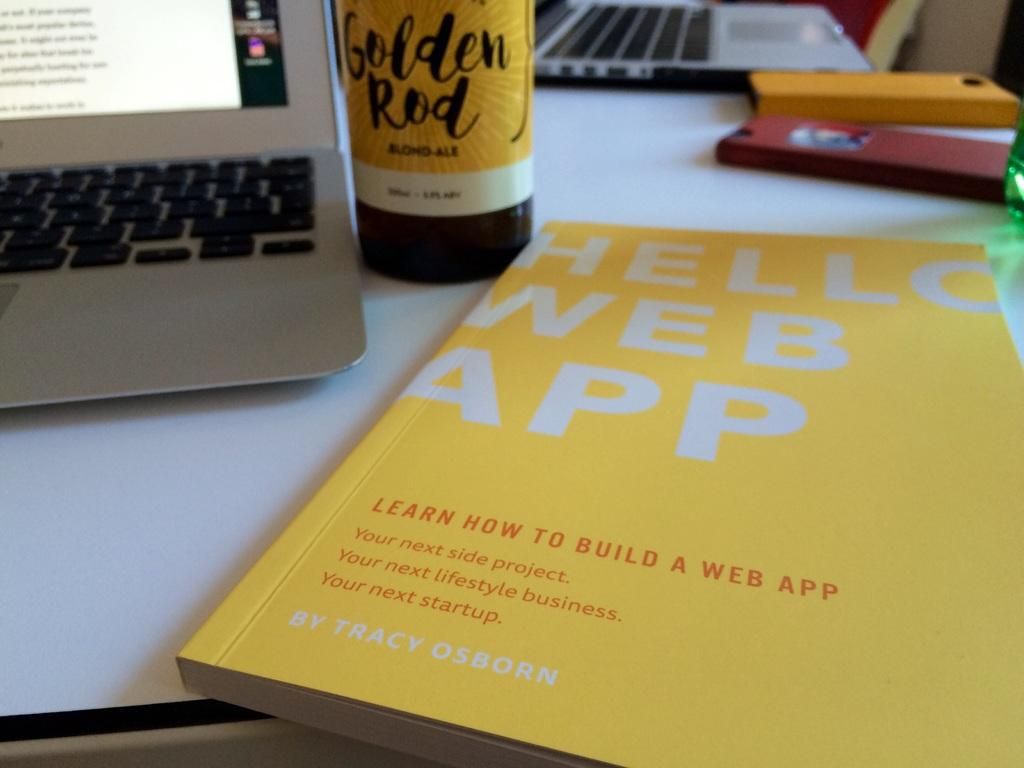<image>
Create a compact narrative representing the image presented. a book that has the word app on the cover 